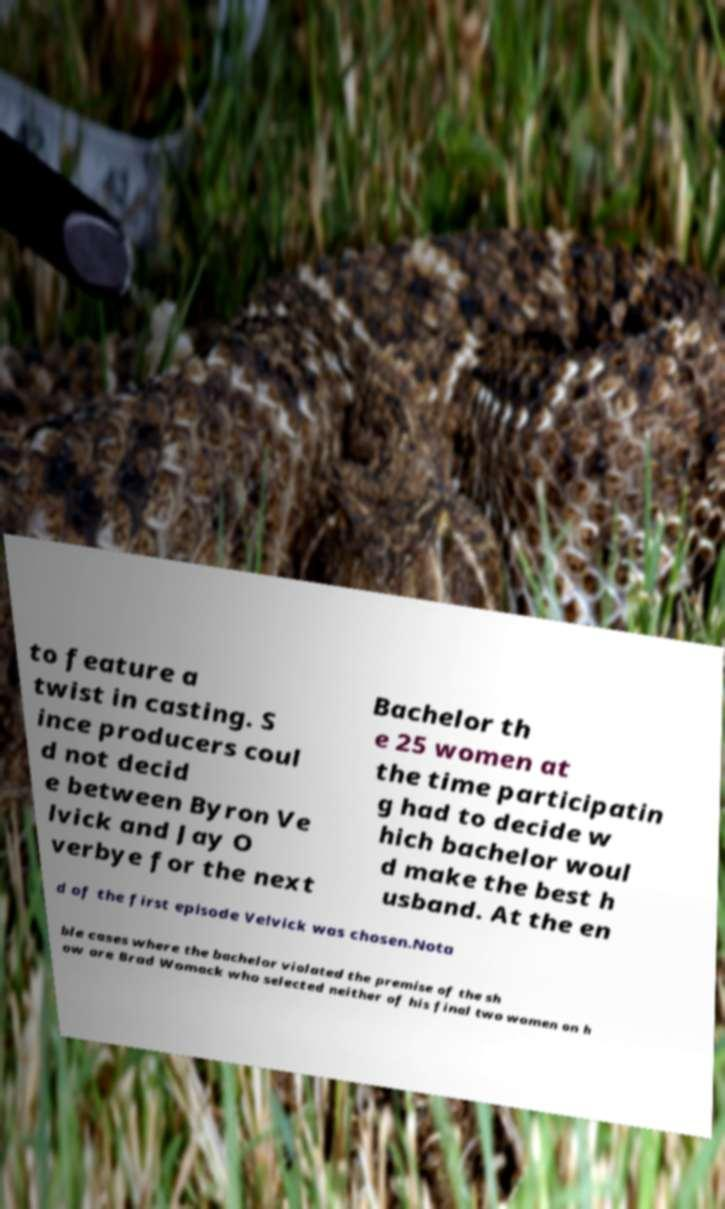There's text embedded in this image that I need extracted. Can you transcribe it verbatim? to feature a twist in casting. S ince producers coul d not decid e between Byron Ve lvick and Jay O verbye for the next Bachelor th e 25 women at the time participatin g had to decide w hich bachelor woul d make the best h usband. At the en d of the first episode Velvick was chosen.Nota ble cases where the bachelor violated the premise of the sh ow are Brad Womack who selected neither of his final two women on h 